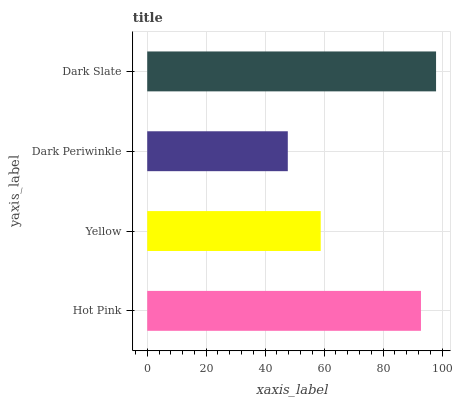Is Dark Periwinkle the minimum?
Answer yes or no. Yes. Is Dark Slate the maximum?
Answer yes or no. Yes. Is Yellow the minimum?
Answer yes or no. No. Is Yellow the maximum?
Answer yes or no. No. Is Hot Pink greater than Yellow?
Answer yes or no. Yes. Is Yellow less than Hot Pink?
Answer yes or no. Yes. Is Yellow greater than Hot Pink?
Answer yes or no. No. Is Hot Pink less than Yellow?
Answer yes or no. No. Is Hot Pink the high median?
Answer yes or no. Yes. Is Yellow the low median?
Answer yes or no. Yes. Is Yellow the high median?
Answer yes or no. No. Is Hot Pink the low median?
Answer yes or no. No. 